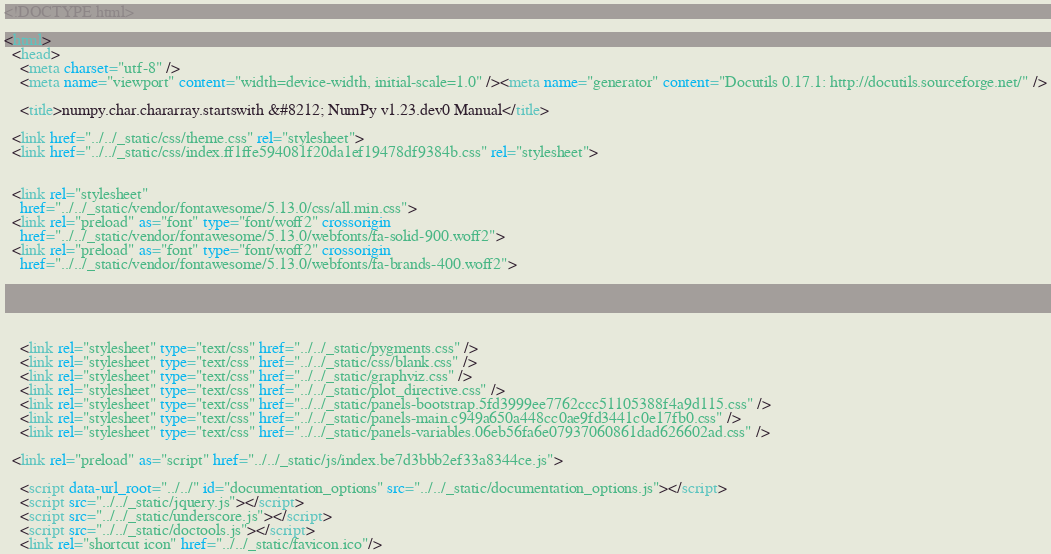<code> <loc_0><loc_0><loc_500><loc_500><_HTML_>
<!DOCTYPE html>

<html>
  <head>
    <meta charset="utf-8" />
    <meta name="viewport" content="width=device-width, initial-scale=1.0" /><meta name="generator" content="Docutils 0.17.1: http://docutils.sourceforge.net/" />

    <title>numpy.char.chararray.startswith &#8212; NumPy v1.23.dev0 Manual</title>
    
  <link href="../../_static/css/theme.css" rel="stylesheet">
  <link href="../../_static/css/index.ff1ffe594081f20da1ef19478df9384b.css" rel="stylesheet">

    
  <link rel="stylesheet"
    href="../../_static/vendor/fontawesome/5.13.0/css/all.min.css">
  <link rel="preload" as="font" type="font/woff2" crossorigin
    href="../../_static/vendor/fontawesome/5.13.0/webfonts/fa-solid-900.woff2">
  <link rel="preload" as="font" type="font/woff2" crossorigin
    href="../../_static/vendor/fontawesome/5.13.0/webfonts/fa-brands-400.woff2">

    
      

    
    <link rel="stylesheet" type="text/css" href="../../_static/pygments.css" />
    <link rel="stylesheet" type="text/css" href="../../_static/css/blank.css" />
    <link rel="stylesheet" type="text/css" href="../../_static/graphviz.css" />
    <link rel="stylesheet" type="text/css" href="../../_static/plot_directive.css" />
    <link rel="stylesheet" type="text/css" href="../../_static/panels-bootstrap.5fd3999ee7762ccc51105388f4a9d115.css" />
    <link rel="stylesheet" type="text/css" href="../../_static/panels-main.c949a650a448cc0ae9fd3441c0e17fb0.css" />
    <link rel="stylesheet" type="text/css" href="../../_static/panels-variables.06eb56fa6e07937060861dad626602ad.css" />
    
  <link rel="preload" as="script" href="../../_static/js/index.be7d3bbb2ef33a8344ce.js">

    <script data-url_root="../../" id="documentation_options" src="../../_static/documentation_options.js"></script>
    <script src="../../_static/jquery.js"></script>
    <script src="../../_static/underscore.js"></script>
    <script src="../../_static/doctools.js"></script>
    <link rel="shortcut icon" href="../../_static/favicon.ico"/></code> 